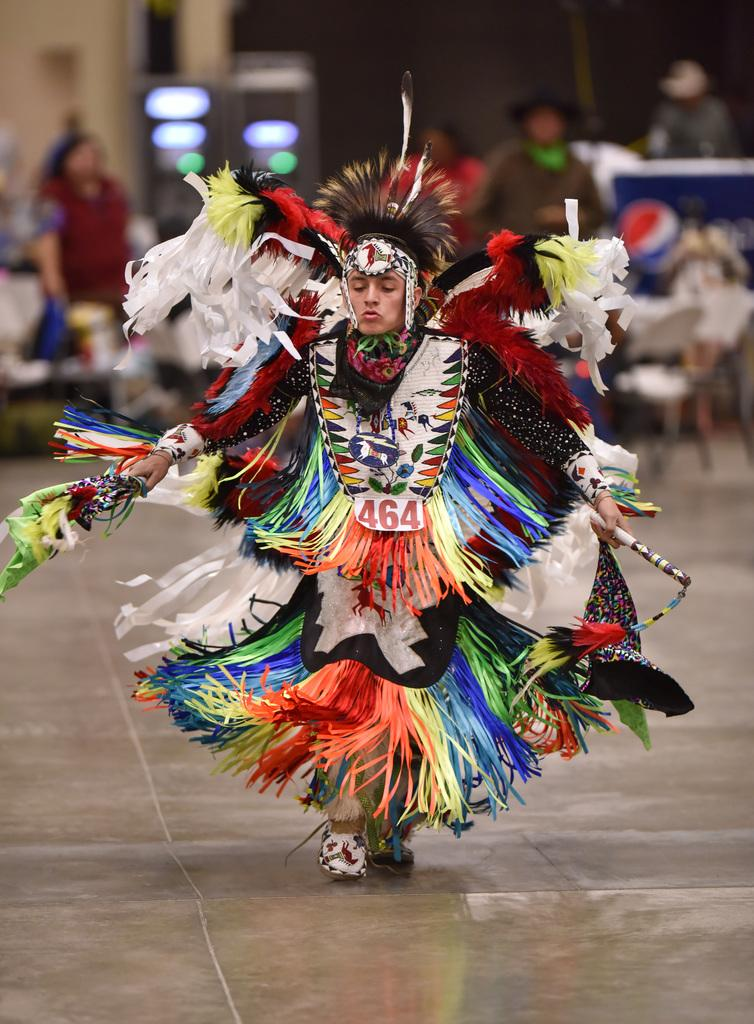What is the person in the foreground of the image wearing? The person is wearing a costume in the image. What can be seen in the background of the image? There are people and chairs in the background of the image. What is visible at the bottom of the image? The floor is visible at the bottom of the image. How does the frog help the person in the costume in the image? There is no frog present in the image, so it cannot help the person in the costume. 